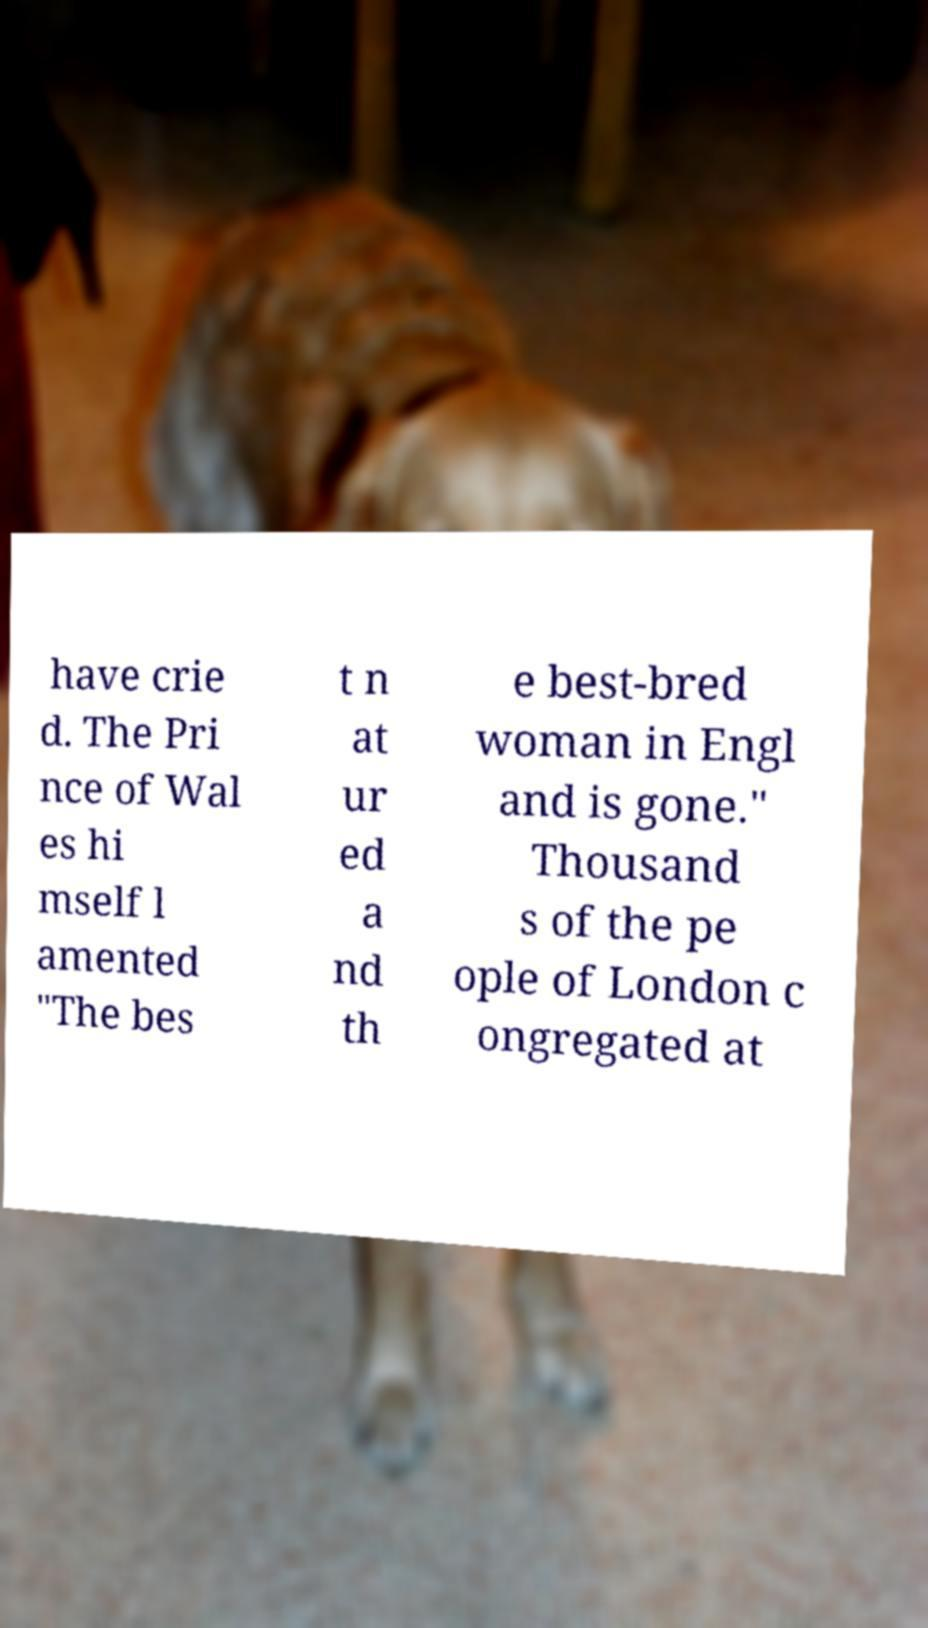Could you extract and type out the text from this image? have crie d. The Pri nce of Wal es hi mself l amented "The bes t n at ur ed a nd th e best-bred woman in Engl and is gone." Thousand s of the pe ople of London c ongregated at 